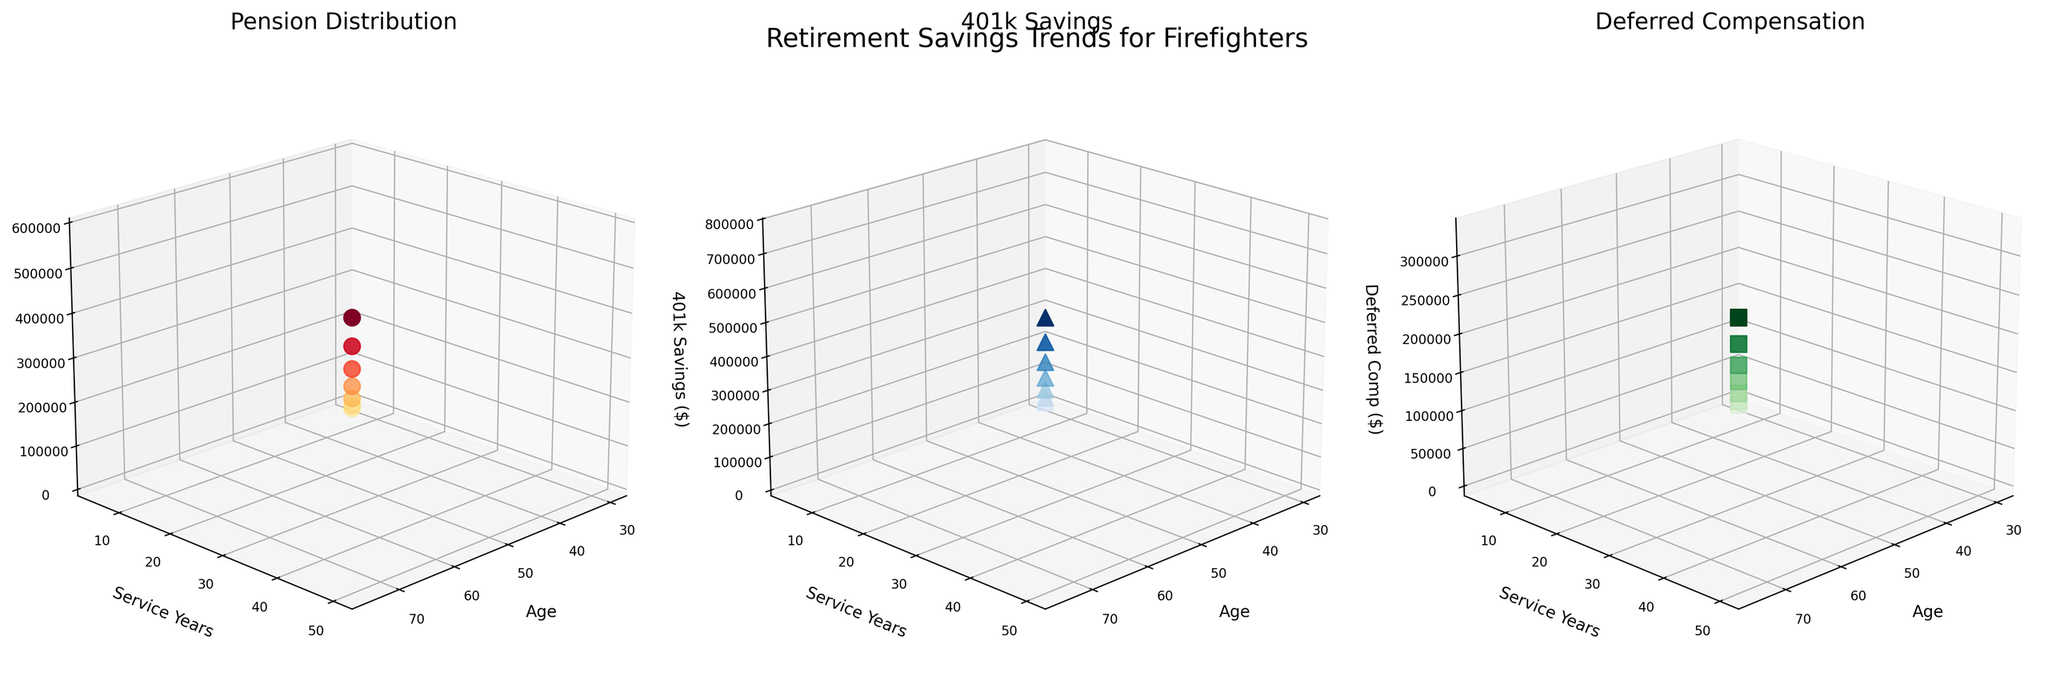What is the title of the plot on the far left? The title can be found at the top of the subplot on the far left. The title is usually in larger font above the plot.
Answer: Pension Distribution How does the color of the points change in the 401k Savings plot? Observe the color scheme in the subplot for 401k Savings. The points become darker with higher 401k Savings values, starting from light blue to dark blue.
Answer: From light blue to dark blue Which plot shows the Deferred Compensation values? Identify the plot by looking at the titles of each subplot. The Deferred Compensation plot is titled 'Deferred Compensation'.
Answer: The plot on the far right What is the Pension Distribution value for someone who is 50 years old with 25 service years? Locate the point in the 'Pension Distribution' subplot that corresponds to Age = 50 and Service Years = 25. The value is near $170,000 in the z-axis.
Answer: $170,000 Which service year group shows the highest 401k savings, and what is the value? In the '401k Savings' plot, look for the point with the highest value on the z-axis. This corresponds to the group with 50 service years and the value is near $750,000.
Answer: 50 service years, $750,000 How do pension distributions generally change with increasing service years? Observe the trend in the 'Pension Distribution' plot. The z-axis values generally increase as the service years increase.
Answer: They increase Compare the Deferred Compensation values for ages 60 and 65. Which age group has a higher value, and by how much? In the Deferred Compensation plot, find the z-axis values for Age = 60 and Age = 65. Age = 65 has a value of $220,000 and Age = 60 has a value of $175,000. The difference is $45,000 higher for Age = 65.
Answer: Age 65, $45,000 What is the average 401k Savings for firefighters with 30 and 35 service years? Look at the 401k Savings subplot and sum the values at 30 and 35 service years ($330,000 and $420,000). Average them: (330,000 + 420,000) / 2 = 375,000.
Answer: $375,000 Which age group has the lowest Deferred Compensation, and what is the value? In the Deferred Compensation plot, locate the lowest point on the z-axis. Age = 30 has the lowest Deferred Compensation value of $10,000.
Answer: Age 30, $10,000 